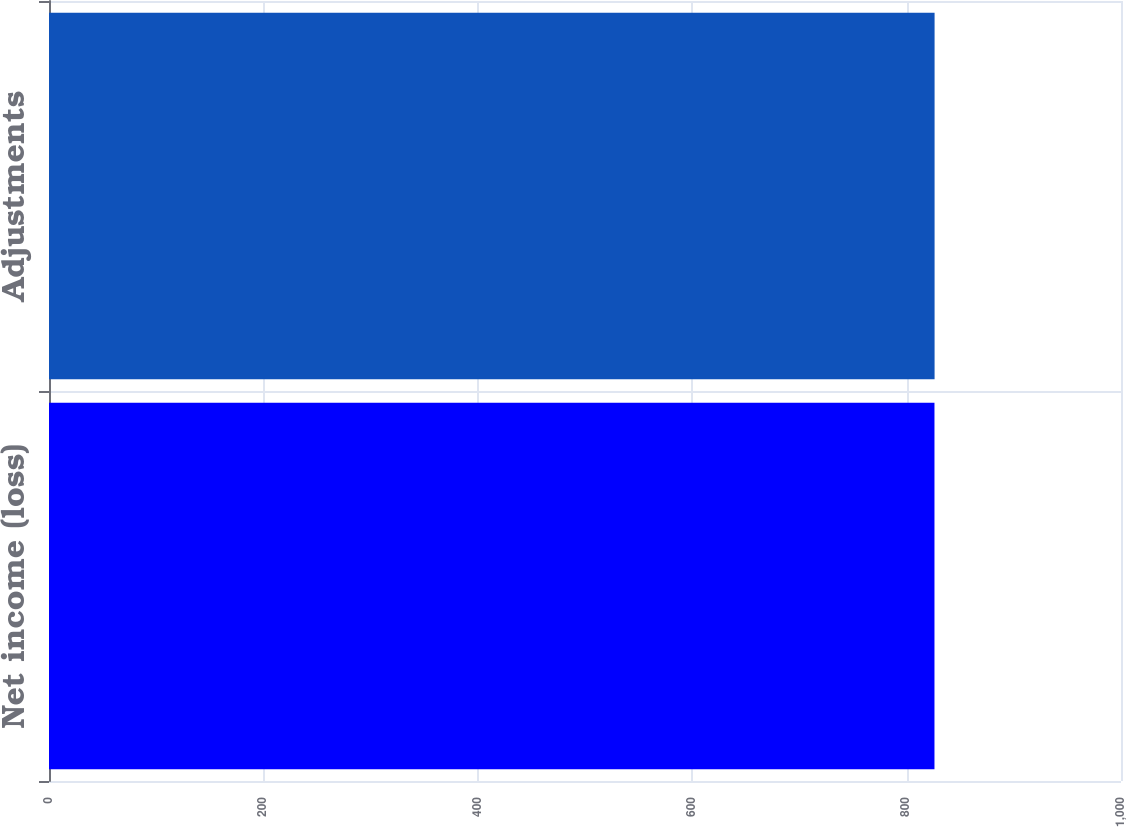Convert chart to OTSL. <chart><loc_0><loc_0><loc_500><loc_500><bar_chart><fcel>Net income (loss)<fcel>Adjustments<nl><fcel>826<fcel>826.1<nl></chart> 